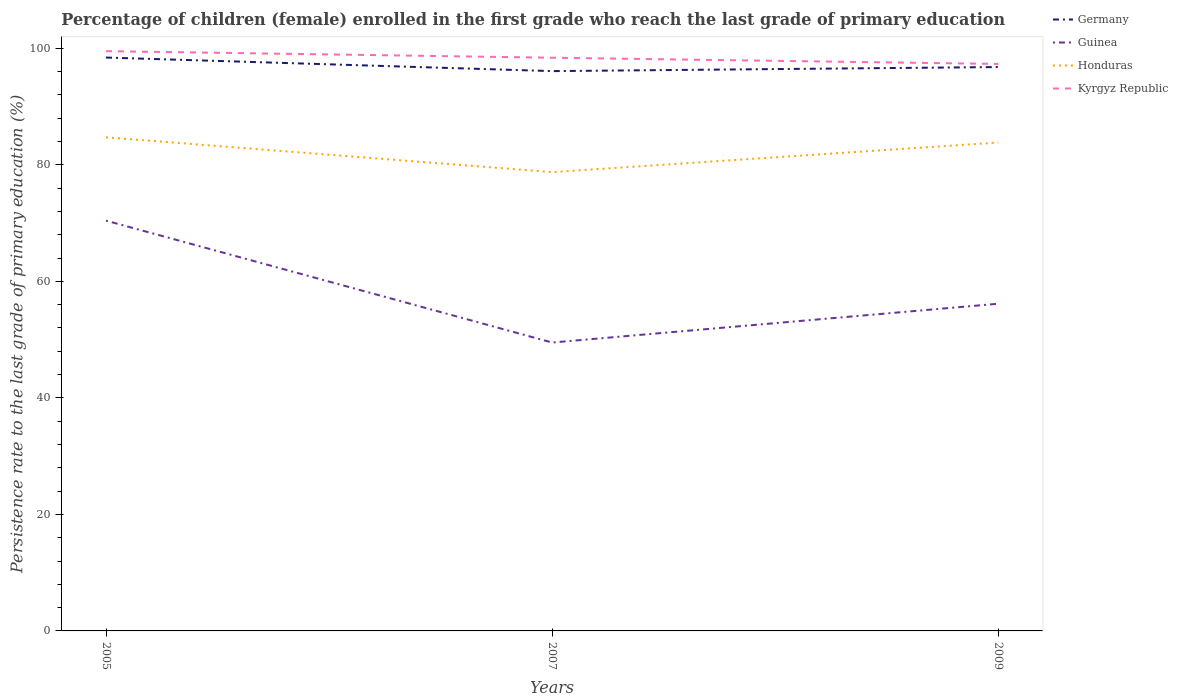How many different coloured lines are there?
Provide a short and direct response. 4. Does the line corresponding to Kyrgyz Republic intersect with the line corresponding to Guinea?
Provide a short and direct response. No. Across all years, what is the maximum persistence rate of children in Germany?
Give a very brief answer. 96.09. What is the total persistence rate of children in Guinea in the graph?
Your response must be concise. -6.66. What is the difference between the highest and the second highest persistence rate of children in Germany?
Offer a very short reply. 2.33. What is the difference between the highest and the lowest persistence rate of children in Honduras?
Provide a short and direct response. 2. Is the persistence rate of children in Honduras strictly greater than the persistence rate of children in Guinea over the years?
Offer a terse response. No. Are the values on the major ticks of Y-axis written in scientific E-notation?
Provide a short and direct response. No. Does the graph contain any zero values?
Give a very brief answer. No. Where does the legend appear in the graph?
Your answer should be compact. Top right. What is the title of the graph?
Offer a terse response. Percentage of children (female) enrolled in the first grade who reach the last grade of primary education. What is the label or title of the X-axis?
Ensure brevity in your answer.  Years. What is the label or title of the Y-axis?
Your answer should be compact. Persistence rate to the last grade of primary education (%). What is the Persistence rate to the last grade of primary education (%) in Germany in 2005?
Keep it short and to the point. 98.42. What is the Persistence rate to the last grade of primary education (%) of Guinea in 2005?
Your answer should be very brief. 70.42. What is the Persistence rate to the last grade of primary education (%) in Honduras in 2005?
Offer a terse response. 84.72. What is the Persistence rate to the last grade of primary education (%) in Kyrgyz Republic in 2005?
Ensure brevity in your answer.  99.52. What is the Persistence rate to the last grade of primary education (%) in Germany in 2007?
Your answer should be compact. 96.09. What is the Persistence rate to the last grade of primary education (%) of Guinea in 2007?
Your answer should be very brief. 49.5. What is the Persistence rate to the last grade of primary education (%) in Honduras in 2007?
Provide a succinct answer. 78.75. What is the Persistence rate to the last grade of primary education (%) of Kyrgyz Republic in 2007?
Give a very brief answer. 98.39. What is the Persistence rate to the last grade of primary education (%) in Germany in 2009?
Ensure brevity in your answer.  96.78. What is the Persistence rate to the last grade of primary education (%) in Guinea in 2009?
Make the answer very short. 56.16. What is the Persistence rate to the last grade of primary education (%) in Honduras in 2009?
Give a very brief answer. 83.83. What is the Persistence rate to the last grade of primary education (%) in Kyrgyz Republic in 2009?
Ensure brevity in your answer.  97.32. Across all years, what is the maximum Persistence rate to the last grade of primary education (%) in Germany?
Provide a succinct answer. 98.42. Across all years, what is the maximum Persistence rate to the last grade of primary education (%) in Guinea?
Keep it short and to the point. 70.42. Across all years, what is the maximum Persistence rate to the last grade of primary education (%) of Honduras?
Provide a succinct answer. 84.72. Across all years, what is the maximum Persistence rate to the last grade of primary education (%) in Kyrgyz Republic?
Your answer should be very brief. 99.52. Across all years, what is the minimum Persistence rate to the last grade of primary education (%) in Germany?
Offer a very short reply. 96.09. Across all years, what is the minimum Persistence rate to the last grade of primary education (%) in Guinea?
Provide a short and direct response. 49.5. Across all years, what is the minimum Persistence rate to the last grade of primary education (%) of Honduras?
Provide a succinct answer. 78.75. Across all years, what is the minimum Persistence rate to the last grade of primary education (%) of Kyrgyz Republic?
Keep it short and to the point. 97.32. What is the total Persistence rate to the last grade of primary education (%) of Germany in the graph?
Provide a short and direct response. 291.29. What is the total Persistence rate to the last grade of primary education (%) in Guinea in the graph?
Ensure brevity in your answer.  176.08. What is the total Persistence rate to the last grade of primary education (%) of Honduras in the graph?
Keep it short and to the point. 247.31. What is the total Persistence rate to the last grade of primary education (%) in Kyrgyz Republic in the graph?
Your answer should be very brief. 295.22. What is the difference between the Persistence rate to the last grade of primary education (%) in Germany in 2005 and that in 2007?
Offer a terse response. 2.33. What is the difference between the Persistence rate to the last grade of primary education (%) of Guinea in 2005 and that in 2007?
Ensure brevity in your answer.  20.92. What is the difference between the Persistence rate to the last grade of primary education (%) in Honduras in 2005 and that in 2007?
Ensure brevity in your answer.  5.97. What is the difference between the Persistence rate to the last grade of primary education (%) of Kyrgyz Republic in 2005 and that in 2007?
Your response must be concise. 1.13. What is the difference between the Persistence rate to the last grade of primary education (%) of Germany in 2005 and that in 2009?
Your answer should be compact. 1.63. What is the difference between the Persistence rate to the last grade of primary education (%) in Guinea in 2005 and that in 2009?
Ensure brevity in your answer.  14.26. What is the difference between the Persistence rate to the last grade of primary education (%) in Honduras in 2005 and that in 2009?
Make the answer very short. 0.89. What is the difference between the Persistence rate to the last grade of primary education (%) of Kyrgyz Republic in 2005 and that in 2009?
Provide a succinct answer. 2.2. What is the difference between the Persistence rate to the last grade of primary education (%) in Germany in 2007 and that in 2009?
Your answer should be compact. -0.7. What is the difference between the Persistence rate to the last grade of primary education (%) in Guinea in 2007 and that in 2009?
Offer a very short reply. -6.66. What is the difference between the Persistence rate to the last grade of primary education (%) in Honduras in 2007 and that in 2009?
Your answer should be compact. -5.08. What is the difference between the Persistence rate to the last grade of primary education (%) in Kyrgyz Republic in 2007 and that in 2009?
Ensure brevity in your answer.  1.07. What is the difference between the Persistence rate to the last grade of primary education (%) in Germany in 2005 and the Persistence rate to the last grade of primary education (%) in Guinea in 2007?
Your answer should be compact. 48.92. What is the difference between the Persistence rate to the last grade of primary education (%) in Germany in 2005 and the Persistence rate to the last grade of primary education (%) in Honduras in 2007?
Give a very brief answer. 19.66. What is the difference between the Persistence rate to the last grade of primary education (%) of Germany in 2005 and the Persistence rate to the last grade of primary education (%) of Kyrgyz Republic in 2007?
Provide a succinct answer. 0.03. What is the difference between the Persistence rate to the last grade of primary education (%) in Guinea in 2005 and the Persistence rate to the last grade of primary education (%) in Honduras in 2007?
Offer a terse response. -8.33. What is the difference between the Persistence rate to the last grade of primary education (%) of Guinea in 2005 and the Persistence rate to the last grade of primary education (%) of Kyrgyz Republic in 2007?
Provide a succinct answer. -27.96. What is the difference between the Persistence rate to the last grade of primary education (%) of Honduras in 2005 and the Persistence rate to the last grade of primary education (%) of Kyrgyz Republic in 2007?
Give a very brief answer. -13.66. What is the difference between the Persistence rate to the last grade of primary education (%) in Germany in 2005 and the Persistence rate to the last grade of primary education (%) in Guinea in 2009?
Give a very brief answer. 42.26. What is the difference between the Persistence rate to the last grade of primary education (%) in Germany in 2005 and the Persistence rate to the last grade of primary education (%) in Honduras in 2009?
Offer a terse response. 14.58. What is the difference between the Persistence rate to the last grade of primary education (%) of Germany in 2005 and the Persistence rate to the last grade of primary education (%) of Kyrgyz Republic in 2009?
Make the answer very short. 1.1. What is the difference between the Persistence rate to the last grade of primary education (%) in Guinea in 2005 and the Persistence rate to the last grade of primary education (%) in Honduras in 2009?
Provide a succinct answer. -13.41. What is the difference between the Persistence rate to the last grade of primary education (%) in Guinea in 2005 and the Persistence rate to the last grade of primary education (%) in Kyrgyz Republic in 2009?
Make the answer very short. -26.9. What is the difference between the Persistence rate to the last grade of primary education (%) in Honduras in 2005 and the Persistence rate to the last grade of primary education (%) in Kyrgyz Republic in 2009?
Your answer should be very brief. -12.59. What is the difference between the Persistence rate to the last grade of primary education (%) of Germany in 2007 and the Persistence rate to the last grade of primary education (%) of Guinea in 2009?
Ensure brevity in your answer.  39.93. What is the difference between the Persistence rate to the last grade of primary education (%) of Germany in 2007 and the Persistence rate to the last grade of primary education (%) of Honduras in 2009?
Offer a very short reply. 12.25. What is the difference between the Persistence rate to the last grade of primary education (%) in Germany in 2007 and the Persistence rate to the last grade of primary education (%) in Kyrgyz Republic in 2009?
Keep it short and to the point. -1.23. What is the difference between the Persistence rate to the last grade of primary education (%) in Guinea in 2007 and the Persistence rate to the last grade of primary education (%) in Honduras in 2009?
Provide a short and direct response. -34.33. What is the difference between the Persistence rate to the last grade of primary education (%) of Guinea in 2007 and the Persistence rate to the last grade of primary education (%) of Kyrgyz Republic in 2009?
Provide a succinct answer. -47.82. What is the difference between the Persistence rate to the last grade of primary education (%) of Honduras in 2007 and the Persistence rate to the last grade of primary education (%) of Kyrgyz Republic in 2009?
Make the answer very short. -18.56. What is the average Persistence rate to the last grade of primary education (%) in Germany per year?
Provide a succinct answer. 97.1. What is the average Persistence rate to the last grade of primary education (%) of Guinea per year?
Your answer should be very brief. 58.69. What is the average Persistence rate to the last grade of primary education (%) in Honduras per year?
Provide a short and direct response. 82.44. What is the average Persistence rate to the last grade of primary education (%) in Kyrgyz Republic per year?
Your response must be concise. 98.41. In the year 2005, what is the difference between the Persistence rate to the last grade of primary education (%) of Germany and Persistence rate to the last grade of primary education (%) of Guinea?
Keep it short and to the point. 27.99. In the year 2005, what is the difference between the Persistence rate to the last grade of primary education (%) in Germany and Persistence rate to the last grade of primary education (%) in Honduras?
Your answer should be compact. 13.69. In the year 2005, what is the difference between the Persistence rate to the last grade of primary education (%) in Germany and Persistence rate to the last grade of primary education (%) in Kyrgyz Republic?
Provide a succinct answer. -1.1. In the year 2005, what is the difference between the Persistence rate to the last grade of primary education (%) of Guinea and Persistence rate to the last grade of primary education (%) of Honduras?
Ensure brevity in your answer.  -14.3. In the year 2005, what is the difference between the Persistence rate to the last grade of primary education (%) of Guinea and Persistence rate to the last grade of primary education (%) of Kyrgyz Republic?
Keep it short and to the point. -29.09. In the year 2005, what is the difference between the Persistence rate to the last grade of primary education (%) in Honduras and Persistence rate to the last grade of primary education (%) in Kyrgyz Republic?
Your answer should be very brief. -14.79. In the year 2007, what is the difference between the Persistence rate to the last grade of primary education (%) of Germany and Persistence rate to the last grade of primary education (%) of Guinea?
Ensure brevity in your answer.  46.59. In the year 2007, what is the difference between the Persistence rate to the last grade of primary education (%) in Germany and Persistence rate to the last grade of primary education (%) in Honduras?
Your response must be concise. 17.33. In the year 2007, what is the difference between the Persistence rate to the last grade of primary education (%) in Germany and Persistence rate to the last grade of primary education (%) in Kyrgyz Republic?
Give a very brief answer. -2.3. In the year 2007, what is the difference between the Persistence rate to the last grade of primary education (%) in Guinea and Persistence rate to the last grade of primary education (%) in Honduras?
Your answer should be compact. -29.25. In the year 2007, what is the difference between the Persistence rate to the last grade of primary education (%) of Guinea and Persistence rate to the last grade of primary education (%) of Kyrgyz Republic?
Offer a very short reply. -48.89. In the year 2007, what is the difference between the Persistence rate to the last grade of primary education (%) in Honduras and Persistence rate to the last grade of primary education (%) in Kyrgyz Republic?
Keep it short and to the point. -19.63. In the year 2009, what is the difference between the Persistence rate to the last grade of primary education (%) in Germany and Persistence rate to the last grade of primary education (%) in Guinea?
Give a very brief answer. 40.62. In the year 2009, what is the difference between the Persistence rate to the last grade of primary education (%) of Germany and Persistence rate to the last grade of primary education (%) of Honduras?
Your answer should be compact. 12.95. In the year 2009, what is the difference between the Persistence rate to the last grade of primary education (%) in Germany and Persistence rate to the last grade of primary education (%) in Kyrgyz Republic?
Provide a short and direct response. -0.53. In the year 2009, what is the difference between the Persistence rate to the last grade of primary education (%) of Guinea and Persistence rate to the last grade of primary education (%) of Honduras?
Keep it short and to the point. -27.67. In the year 2009, what is the difference between the Persistence rate to the last grade of primary education (%) of Guinea and Persistence rate to the last grade of primary education (%) of Kyrgyz Republic?
Give a very brief answer. -41.16. In the year 2009, what is the difference between the Persistence rate to the last grade of primary education (%) of Honduras and Persistence rate to the last grade of primary education (%) of Kyrgyz Republic?
Provide a succinct answer. -13.48. What is the ratio of the Persistence rate to the last grade of primary education (%) in Germany in 2005 to that in 2007?
Your answer should be very brief. 1.02. What is the ratio of the Persistence rate to the last grade of primary education (%) in Guinea in 2005 to that in 2007?
Offer a terse response. 1.42. What is the ratio of the Persistence rate to the last grade of primary education (%) in Honduras in 2005 to that in 2007?
Give a very brief answer. 1.08. What is the ratio of the Persistence rate to the last grade of primary education (%) in Kyrgyz Republic in 2005 to that in 2007?
Keep it short and to the point. 1.01. What is the ratio of the Persistence rate to the last grade of primary education (%) in Germany in 2005 to that in 2009?
Your answer should be compact. 1.02. What is the ratio of the Persistence rate to the last grade of primary education (%) of Guinea in 2005 to that in 2009?
Provide a short and direct response. 1.25. What is the ratio of the Persistence rate to the last grade of primary education (%) in Honduras in 2005 to that in 2009?
Provide a succinct answer. 1.01. What is the ratio of the Persistence rate to the last grade of primary education (%) of Kyrgyz Republic in 2005 to that in 2009?
Your answer should be very brief. 1.02. What is the ratio of the Persistence rate to the last grade of primary education (%) in Guinea in 2007 to that in 2009?
Ensure brevity in your answer.  0.88. What is the ratio of the Persistence rate to the last grade of primary education (%) of Honduras in 2007 to that in 2009?
Provide a short and direct response. 0.94. What is the ratio of the Persistence rate to the last grade of primary education (%) of Kyrgyz Republic in 2007 to that in 2009?
Keep it short and to the point. 1.01. What is the difference between the highest and the second highest Persistence rate to the last grade of primary education (%) of Germany?
Your response must be concise. 1.63. What is the difference between the highest and the second highest Persistence rate to the last grade of primary education (%) in Guinea?
Make the answer very short. 14.26. What is the difference between the highest and the second highest Persistence rate to the last grade of primary education (%) in Honduras?
Ensure brevity in your answer.  0.89. What is the difference between the highest and the second highest Persistence rate to the last grade of primary education (%) of Kyrgyz Republic?
Ensure brevity in your answer.  1.13. What is the difference between the highest and the lowest Persistence rate to the last grade of primary education (%) of Germany?
Offer a very short reply. 2.33. What is the difference between the highest and the lowest Persistence rate to the last grade of primary education (%) in Guinea?
Your answer should be very brief. 20.92. What is the difference between the highest and the lowest Persistence rate to the last grade of primary education (%) of Honduras?
Offer a very short reply. 5.97. What is the difference between the highest and the lowest Persistence rate to the last grade of primary education (%) in Kyrgyz Republic?
Offer a very short reply. 2.2. 